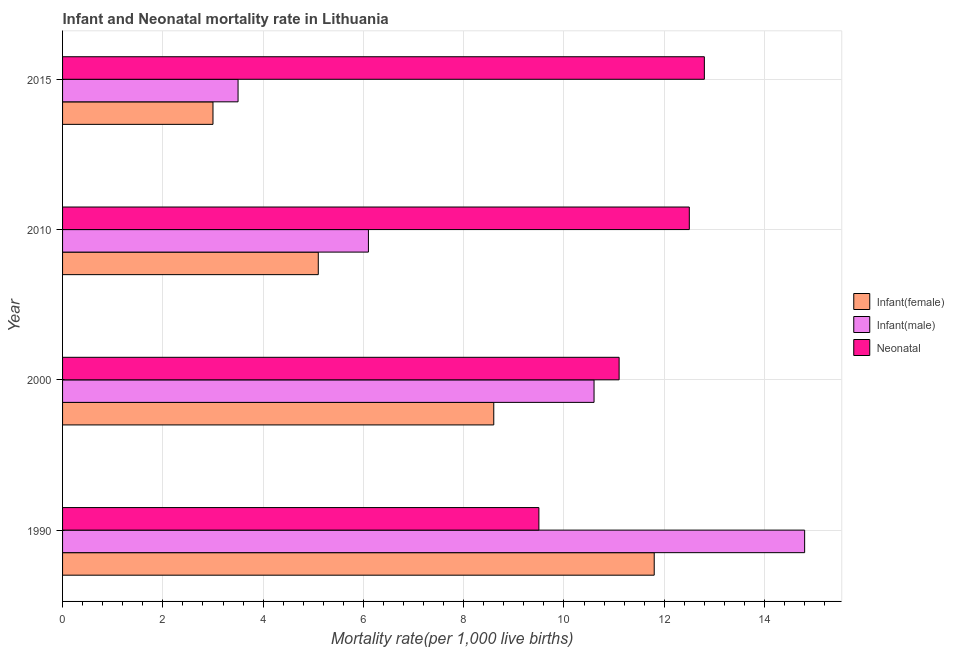How many groups of bars are there?
Your answer should be compact. 4. Are the number of bars on each tick of the Y-axis equal?
Give a very brief answer. Yes. How many bars are there on the 4th tick from the bottom?
Give a very brief answer. 3. What is the label of the 2nd group of bars from the top?
Offer a very short reply. 2010. In how many cases, is the number of bars for a given year not equal to the number of legend labels?
Keep it short and to the point. 0. In which year was the infant mortality rate(male) maximum?
Give a very brief answer. 1990. In which year was the infant mortality rate(female) minimum?
Provide a succinct answer. 2015. What is the difference between the neonatal mortality rate in 2010 and that in 2015?
Offer a very short reply. -0.3. What is the difference between the infant mortality rate(male) in 2000 and the neonatal mortality rate in 2015?
Offer a terse response. -2.2. What is the average neonatal mortality rate per year?
Ensure brevity in your answer.  11.47. In the year 2000, what is the difference between the infant mortality rate(male) and infant mortality rate(female)?
Ensure brevity in your answer.  2. In how many years, is the neonatal mortality rate greater than 13.6 ?
Your answer should be very brief. 0. What is the ratio of the infant mortality rate(female) in 1990 to that in 2010?
Offer a very short reply. 2.31. Is the neonatal mortality rate in 2000 less than that in 2015?
Give a very brief answer. Yes. What does the 2nd bar from the top in 2015 represents?
Provide a short and direct response. Infant(male). What does the 1st bar from the bottom in 2015 represents?
Offer a terse response. Infant(female). Is it the case that in every year, the sum of the infant mortality rate(female) and infant mortality rate(male) is greater than the neonatal mortality rate?
Make the answer very short. No. What is the difference between two consecutive major ticks on the X-axis?
Ensure brevity in your answer.  2. Are the values on the major ticks of X-axis written in scientific E-notation?
Keep it short and to the point. No. Does the graph contain any zero values?
Ensure brevity in your answer.  No. Does the graph contain grids?
Offer a terse response. Yes. Where does the legend appear in the graph?
Offer a very short reply. Center right. How many legend labels are there?
Your response must be concise. 3. How are the legend labels stacked?
Offer a very short reply. Vertical. What is the title of the graph?
Ensure brevity in your answer.  Infant and Neonatal mortality rate in Lithuania. Does "Ages 50+" appear as one of the legend labels in the graph?
Your answer should be very brief. No. What is the label or title of the X-axis?
Your answer should be very brief. Mortality rate(per 1,0 live births). What is the label or title of the Y-axis?
Offer a very short reply. Year. What is the Mortality rate(per 1,000 live births) in Infant(female) in 2000?
Offer a terse response. 8.6. What is the Mortality rate(per 1,000 live births) of Infant(female) in 2010?
Offer a terse response. 5.1. What is the Mortality rate(per 1,000 live births) in Infant(male) in 2010?
Offer a terse response. 6.1. What is the Mortality rate(per 1,000 live births) in Infant(female) in 2015?
Give a very brief answer. 3. Across all years, what is the maximum Mortality rate(per 1,000 live births) of Infant(male)?
Offer a terse response. 14.8. Across all years, what is the maximum Mortality rate(per 1,000 live births) of Neonatal ?
Your response must be concise. 12.8. Across all years, what is the minimum Mortality rate(per 1,000 live births) in Infant(male)?
Ensure brevity in your answer.  3.5. What is the total Mortality rate(per 1,000 live births) of Infant(male) in the graph?
Your answer should be compact. 35. What is the total Mortality rate(per 1,000 live births) of Neonatal  in the graph?
Your answer should be very brief. 45.9. What is the difference between the Mortality rate(per 1,000 live births) in Infant(female) in 1990 and that in 2000?
Provide a succinct answer. 3.2. What is the difference between the Mortality rate(per 1,000 live births) of Infant(male) in 1990 and that in 2000?
Offer a very short reply. 4.2. What is the difference between the Mortality rate(per 1,000 live births) in Infant(female) in 1990 and that in 2010?
Provide a short and direct response. 6.7. What is the difference between the Mortality rate(per 1,000 live births) in Neonatal  in 1990 and that in 2010?
Offer a very short reply. -3. What is the difference between the Mortality rate(per 1,000 live births) in Infant(female) in 1990 and that in 2015?
Provide a succinct answer. 8.8. What is the difference between the Mortality rate(per 1,000 live births) of Infant(male) in 1990 and that in 2015?
Your response must be concise. 11.3. What is the difference between the Mortality rate(per 1,000 live births) of Neonatal  in 1990 and that in 2015?
Your response must be concise. -3.3. What is the difference between the Mortality rate(per 1,000 live births) in Infant(female) in 2000 and that in 2010?
Provide a succinct answer. 3.5. What is the difference between the Mortality rate(per 1,000 live births) in Neonatal  in 2000 and that in 2015?
Keep it short and to the point. -1.7. What is the difference between the Mortality rate(per 1,000 live births) in Neonatal  in 2010 and that in 2015?
Offer a very short reply. -0.3. What is the difference between the Mortality rate(per 1,000 live births) in Infant(female) in 1990 and the Mortality rate(per 1,000 live births) in Infant(male) in 2000?
Give a very brief answer. 1.2. What is the difference between the Mortality rate(per 1,000 live births) of Infant(female) in 1990 and the Mortality rate(per 1,000 live births) of Neonatal  in 2000?
Make the answer very short. 0.7. What is the difference between the Mortality rate(per 1,000 live births) in Infant(female) in 1990 and the Mortality rate(per 1,000 live births) in Infant(male) in 2010?
Your answer should be compact. 5.7. What is the difference between the Mortality rate(per 1,000 live births) in Infant(female) in 1990 and the Mortality rate(per 1,000 live births) in Neonatal  in 2010?
Provide a succinct answer. -0.7. What is the difference between the Mortality rate(per 1,000 live births) in Infant(male) in 1990 and the Mortality rate(per 1,000 live births) in Neonatal  in 2010?
Offer a terse response. 2.3. What is the difference between the Mortality rate(per 1,000 live births) of Infant(female) in 1990 and the Mortality rate(per 1,000 live births) of Infant(male) in 2015?
Offer a very short reply. 8.3. What is the difference between the Mortality rate(per 1,000 live births) of Infant(female) in 1990 and the Mortality rate(per 1,000 live births) of Neonatal  in 2015?
Provide a short and direct response. -1. What is the difference between the Mortality rate(per 1,000 live births) in Infant(female) in 2000 and the Mortality rate(per 1,000 live births) in Infant(male) in 2010?
Provide a short and direct response. 2.5. What is the difference between the Mortality rate(per 1,000 live births) of Infant(female) in 2000 and the Mortality rate(per 1,000 live births) of Neonatal  in 2010?
Provide a succinct answer. -3.9. What is the difference between the Mortality rate(per 1,000 live births) of Infant(male) in 2000 and the Mortality rate(per 1,000 live births) of Neonatal  in 2010?
Keep it short and to the point. -1.9. What is the difference between the Mortality rate(per 1,000 live births) of Infant(male) in 2000 and the Mortality rate(per 1,000 live births) of Neonatal  in 2015?
Your response must be concise. -2.2. What is the difference between the Mortality rate(per 1,000 live births) of Infant(female) in 2010 and the Mortality rate(per 1,000 live births) of Neonatal  in 2015?
Your answer should be compact. -7.7. What is the average Mortality rate(per 1,000 live births) in Infant(female) per year?
Provide a short and direct response. 7.12. What is the average Mortality rate(per 1,000 live births) in Infant(male) per year?
Offer a very short reply. 8.75. What is the average Mortality rate(per 1,000 live births) of Neonatal  per year?
Offer a terse response. 11.47. In the year 1990, what is the difference between the Mortality rate(per 1,000 live births) of Infant(female) and Mortality rate(per 1,000 live births) of Infant(male)?
Offer a very short reply. -3. In the year 1990, what is the difference between the Mortality rate(per 1,000 live births) of Infant(female) and Mortality rate(per 1,000 live births) of Neonatal ?
Offer a very short reply. 2.3. In the year 1990, what is the difference between the Mortality rate(per 1,000 live births) of Infant(male) and Mortality rate(per 1,000 live births) of Neonatal ?
Your response must be concise. 5.3. In the year 2000, what is the difference between the Mortality rate(per 1,000 live births) in Infant(female) and Mortality rate(per 1,000 live births) in Infant(male)?
Your answer should be very brief. -2. In the year 2010, what is the difference between the Mortality rate(per 1,000 live births) of Infant(female) and Mortality rate(per 1,000 live births) of Neonatal ?
Keep it short and to the point. -7.4. In the year 2010, what is the difference between the Mortality rate(per 1,000 live births) of Infant(male) and Mortality rate(per 1,000 live births) of Neonatal ?
Provide a short and direct response. -6.4. In the year 2015, what is the difference between the Mortality rate(per 1,000 live births) of Infant(female) and Mortality rate(per 1,000 live births) of Infant(male)?
Offer a terse response. -0.5. In the year 2015, what is the difference between the Mortality rate(per 1,000 live births) in Infant(male) and Mortality rate(per 1,000 live births) in Neonatal ?
Give a very brief answer. -9.3. What is the ratio of the Mortality rate(per 1,000 live births) of Infant(female) in 1990 to that in 2000?
Your answer should be compact. 1.37. What is the ratio of the Mortality rate(per 1,000 live births) of Infant(male) in 1990 to that in 2000?
Offer a very short reply. 1.4. What is the ratio of the Mortality rate(per 1,000 live births) of Neonatal  in 1990 to that in 2000?
Keep it short and to the point. 0.86. What is the ratio of the Mortality rate(per 1,000 live births) in Infant(female) in 1990 to that in 2010?
Make the answer very short. 2.31. What is the ratio of the Mortality rate(per 1,000 live births) in Infant(male) in 1990 to that in 2010?
Your response must be concise. 2.43. What is the ratio of the Mortality rate(per 1,000 live births) of Neonatal  in 1990 to that in 2010?
Offer a very short reply. 0.76. What is the ratio of the Mortality rate(per 1,000 live births) in Infant(female) in 1990 to that in 2015?
Give a very brief answer. 3.93. What is the ratio of the Mortality rate(per 1,000 live births) in Infant(male) in 1990 to that in 2015?
Your response must be concise. 4.23. What is the ratio of the Mortality rate(per 1,000 live births) in Neonatal  in 1990 to that in 2015?
Offer a terse response. 0.74. What is the ratio of the Mortality rate(per 1,000 live births) of Infant(female) in 2000 to that in 2010?
Your response must be concise. 1.69. What is the ratio of the Mortality rate(per 1,000 live births) in Infant(male) in 2000 to that in 2010?
Your answer should be very brief. 1.74. What is the ratio of the Mortality rate(per 1,000 live births) of Neonatal  in 2000 to that in 2010?
Provide a short and direct response. 0.89. What is the ratio of the Mortality rate(per 1,000 live births) in Infant(female) in 2000 to that in 2015?
Give a very brief answer. 2.87. What is the ratio of the Mortality rate(per 1,000 live births) of Infant(male) in 2000 to that in 2015?
Offer a very short reply. 3.03. What is the ratio of the Mortality rate(per 1,000 live births) in Neonatal  in 2000 to that in 2015?
Provide a succinct answer. 0.87. What is the ratio of the Mortality rate(per 1,000 live births) of Infant(female) in 2010 to that in 2015?
Your answer should be compact. 1.7. What is the ratio of the Mortality rate(per 1,000 live births) in Infant(male) in 2010 to that in 2015?
Give a very brief answer. 1.74. What is the ratio of the Mortality rate(per 1,000 live births) of Neonatal  in 2010 to that in 2015?
Give a very brief answer. 0.98. What is the difference between the highest and the second highest Mortality rate(per 1,000 live births) in Infant(female)?
Give a very brief answer. 3.2. What is the difference between the highest and the second highest Mortality rate(per 1,000 live births) in Neonatal ?
Provide a succinct answer. 0.3. What is the difference between the highest and the lowest Mortality rate(per 1,000 live births) in Infant(female)?
Provide a short and direct response. 8.8. What is the difference between the highest and the lowest Mortality rate(per 1,000 live births) of Infant(male)?
Give a very brief answer. 11.3. What is the difference between the highest and the lowest Mortality rate(per 1,000 live births) of Neonatal ?
Keep it short and to the point. 3.3. 